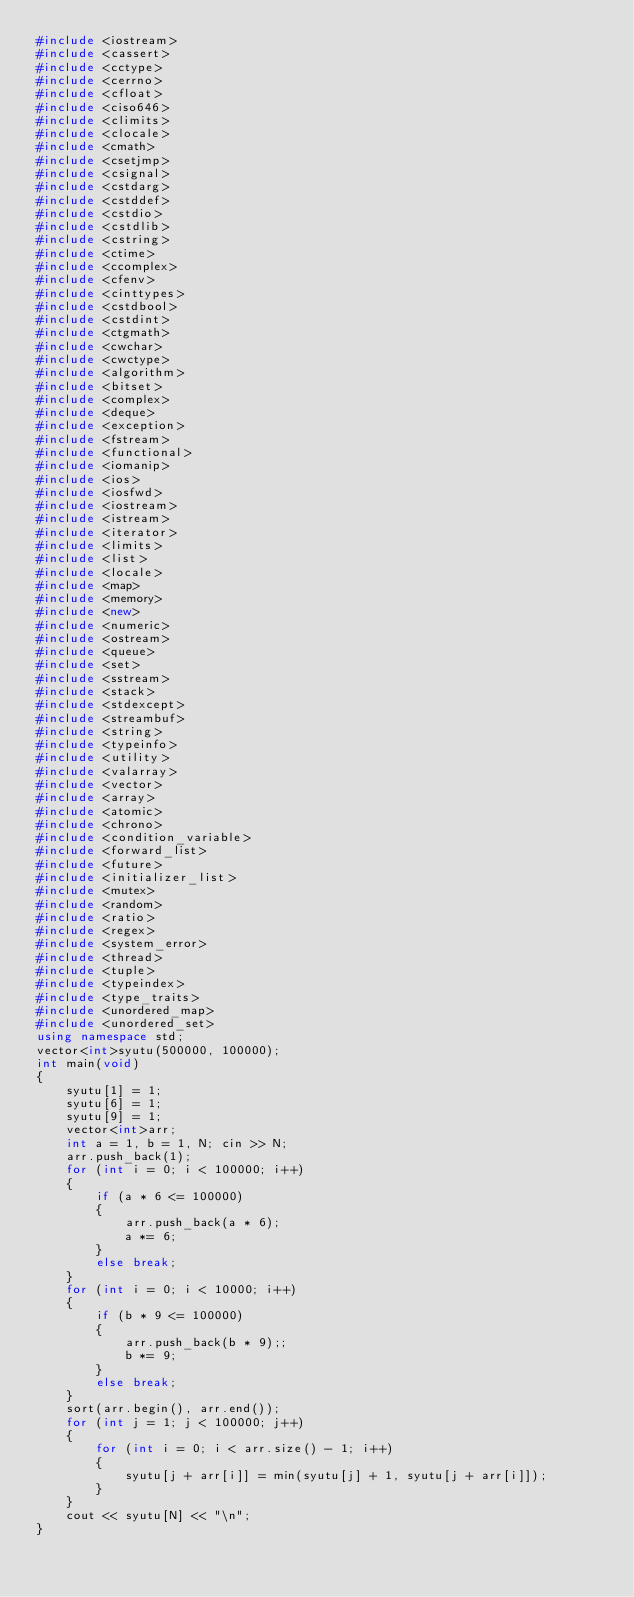<code> <loc_0><loc_0><loc_500><loc_500><_C++_>#include <iostream>
#include <cassert>
#include <cctype>
#include <cerrno>
#include <cfloat>
#include <ciso646>
#include <climits>
#include <clocale>
#include <cmath>
#include <csetjmp>
#include <csignal>
#include <cstdarg>
#include <cstddef>
#include <cstdio>
#include <cstdlib>
#include <cstring>
#include <ctime>
#include <ccomplex>
#include <cfenv>
#include <cinttypes>
#include <cstdbool>
#include <cstdint>
#include <ctgmath>
#include <cwchar>
#include <cwctype>
#include <algorithm>
#include <bitset>
#include <complex>
#include <deque>
#include <exception>
#include <fstream>
#include <functional>
#include <iomanip>
#include <ios>
#include <iosfwd>
#include <iostream>
#include <istream>
#include <iterator>
#include <limits>
#include <list>
#include <locale>
#include <map>
#include <memory>
#include <new>
#include <numeric>
#include <ostream>
#include <queue>
#include <set>
#include <sstream>
#include <stack>
#include <stdexcept>
#include <streambuf>
#include <string>
#include <typeinfo>
#include <utility>
#include <valarray>
#include <vector>
#include <array>
#include <atomic>
#include <chrono>
#include <condition_variable>
#include <forward_list>
#include <future>
#include <initializer_list>
#include <mutex>
#include <random>
#include <ratio>
#include <regex>
#include <system_error>
#include <thread>
#include <tuple>
#include <typeindex>
#include <type_traits>
#include <unordered_map>
#include <unordered_set>
using namespace std;
vector<int>syutu(500000, 100000);
int main(void)
{
	syutu[1] = 1;
	syutu[6] = 1;
	syutu[9] = 1;
	vector<int>arr;
	int a = 1, b = 1, N; cin >> N;
	arr.push_back(1);
	for (int i = 0; i < 100000; i++)
	{
		if (a * 6 <= 100000)
		{
			arr.push_back(a * 6);
			a *= 6;
		}
		else break;
	}
	for (int i = 0; i < 10000; i++)
	{
		if (b * 9 <= 100000)
		{
			arr.push_back(b * 9);;
			b *= 9;
		}
		else break;
	}
	sort(arr.begin(), arr.end());
	for (int j = 1; j < 100000; j++)
	{
		for (int i = 0; i < arr.size() - 1; i++)
		{
			syutu[j + arr[i]] = min(syutu[j] + 1, syutu[j + arr[i]]);
		}
	}
	cout << syutu[N] << "\n";
}

</code> 